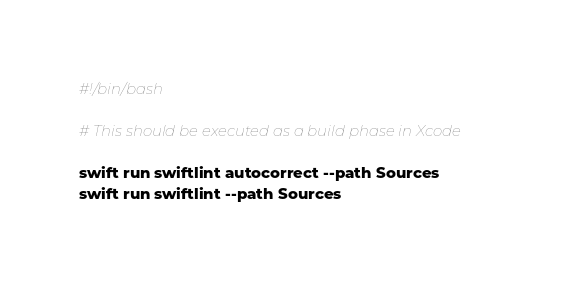Convert code to text. <code><loc_0><loc_0><loc_500><loc_500><_Bash_>#!/bin/bash

# This should be executed as a build phase in Xcode

swift run swiftlint autocorrect --path Sources
swift run swiftlint --path Sources
</code> 